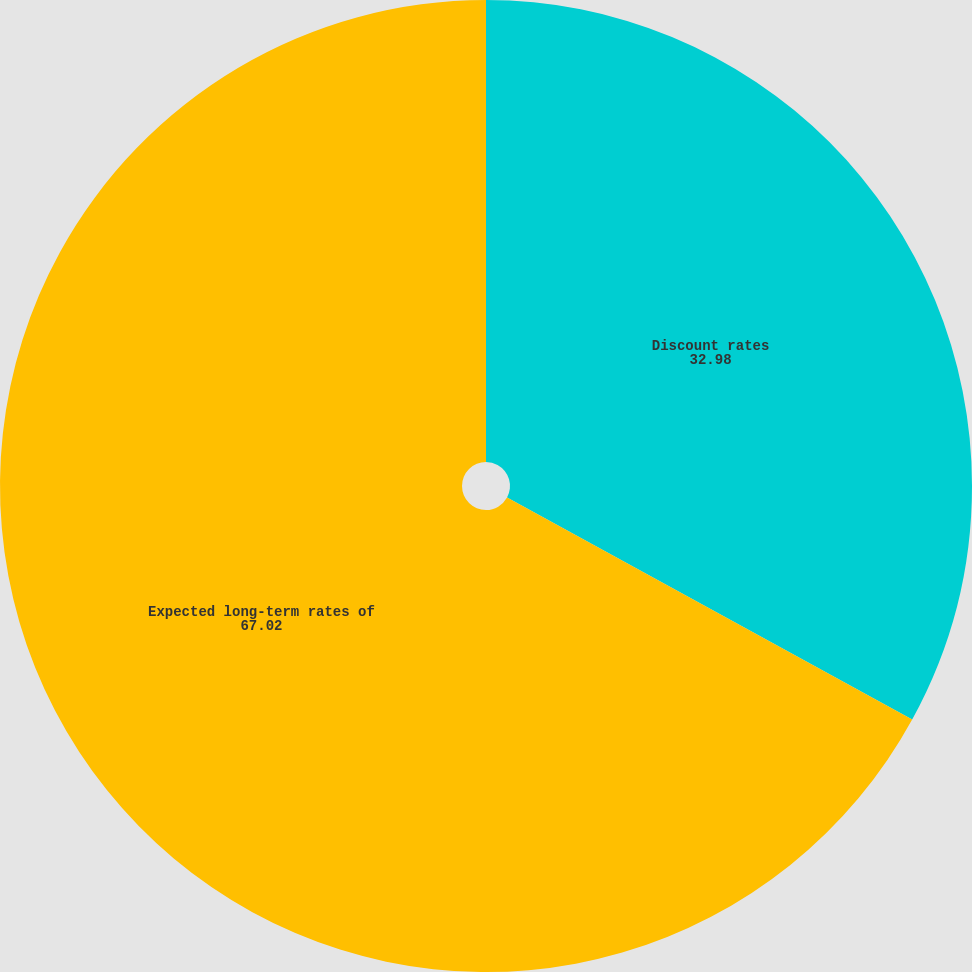<chart> <loc_0><loc_0><loc_500><loc_500><pie_chart><fcel>Discount rates<fcel>Expected long-term rates of<nl><fcel>32.98%<fcel>67.02%<nl></chart> 